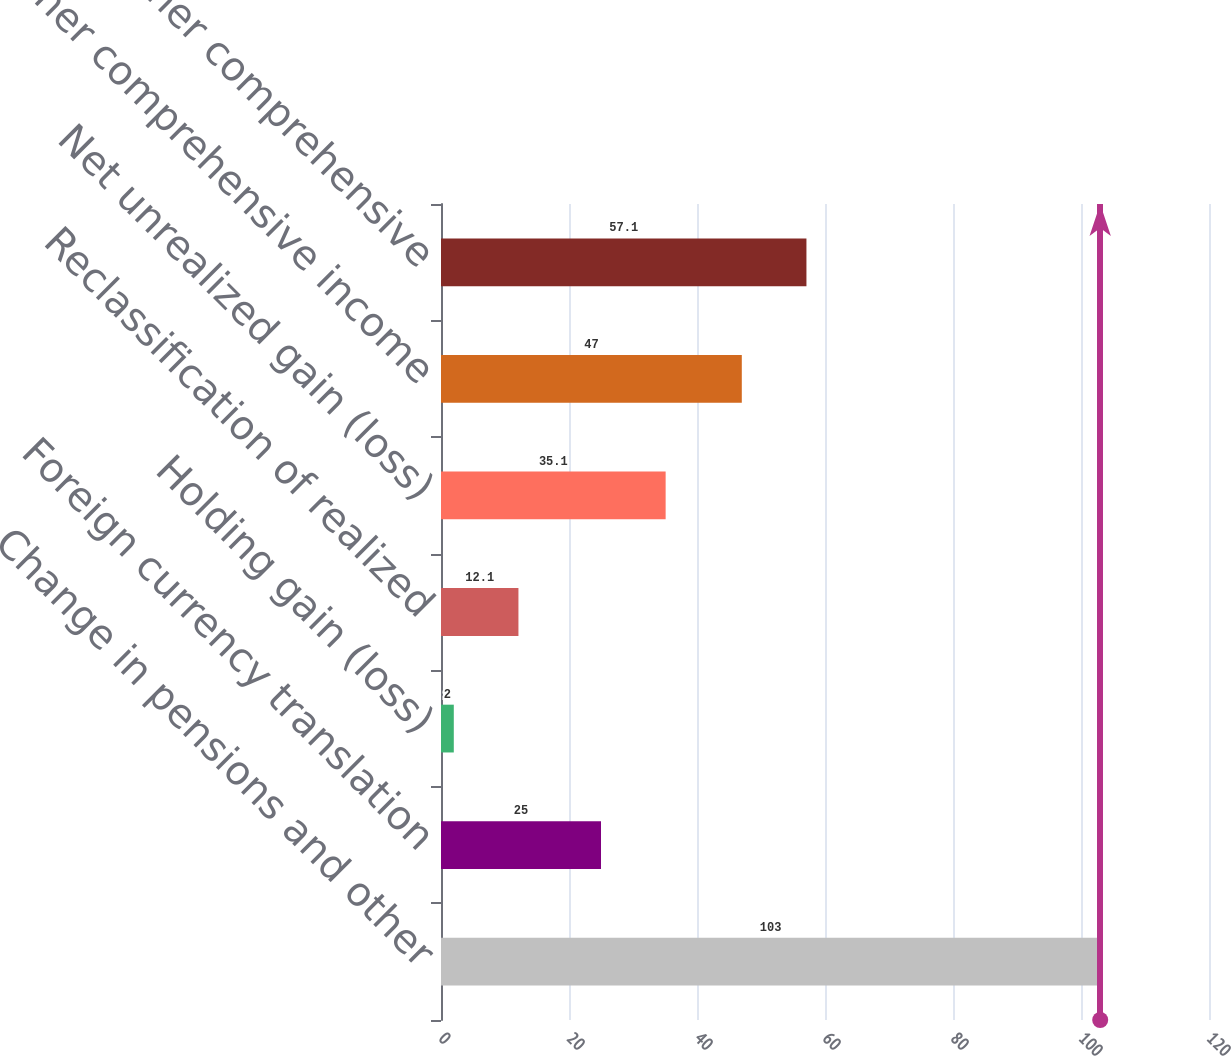<chart> <loc_0><loc_0><loc_500><loc_500><bar_chart><fcel>Change in pensions and other<fcel>Foreign currency translation<fcel>Holding gain (loss)<fcel>Reclassification of realized<fcel>Net unrealized gain (loss)<fcel>Other comprehensive income<fcel>Total other comprehensive<nl><fcel>103<fcel>25<fcel>2<fcel>12.1<fcel>35.1<fcel>47<fcel>57.1<nl></chart> 